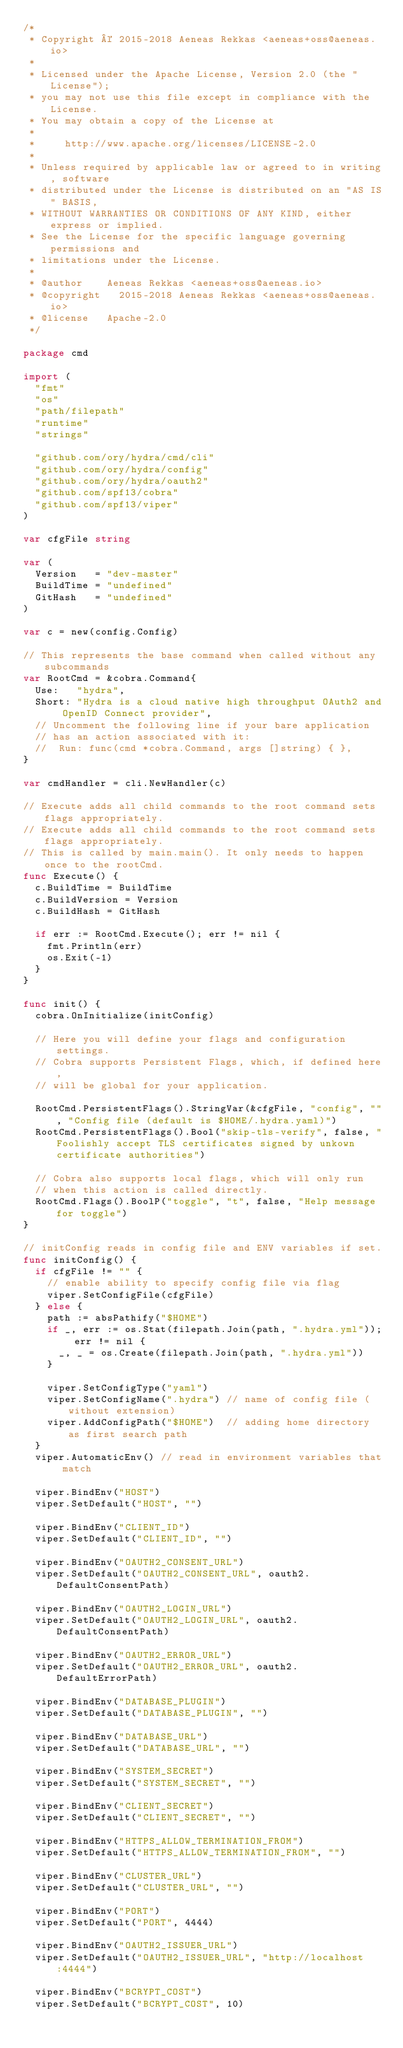<code> <loc_0><loc_0><loc_500><loc_500><_Go_>/*
 * Copyright © 2015-2018 Aeneas Rekkas <aeneas+oss@aeneas.io>
 *
 * Licensed under the Apache License, Version 2.0 (the "License");
 * you may not use this file except in compliance with the License.
 * You may obtain a copy of the License at
 *
 *     http://www.apache.org/licenses/LICENSE-2.0
 *
 * Unless required by applicable law or agreed to in writing, software
 * distributed under the License is distributed on an "AS IS" BASIS,
 * WITHOUT WARRANTIES OR CONDITIONS OF ANY KIND, either express or implied.
 * See the License for the specific language governing permissions and
 * limitations under the License.
 *
 * @author		Aeneas Rekkas <aeneas+oss@aeneas.io>
 * @copyright 	2015-2018 Aeneas Rekkas <aeneas+oss@aeneas.io>
 * @license 	Apache-2.0
 */

package cmd

import (
	"fmt"
	"os"
	"path/filepath"
	"runtime"
	"strings"

	"github.com/ory/hydra/cmd/cli"
	"github.com/ory/hydra/config"
	"github.com/ory/hydra/oauth2"
	"github.com/spf13/cobra"
	"github.com/spf13/viper"
)

var cfgFile string

var (
	Version   = "dev-master"
	BuildTime = "undefined"
	GitHash   = "undefined"
)

var c = new(config.Config)

// This represents the base command when called without any subcommands
var RootCmd = &cobra.Command{
	Use:   "hydra",
	Short: "Hydra is a cloud native high throughput OAuth2 and OpenID Connect provider",
	// Uncomment the following line if your bare application
	// has an action associated with it:
	//	Run: func(cmd *cobra.Command, args []string) { },
}

var cmdHandler = cli.NewHandler(c)

// Execute adds all child commands to the root command sets flags appropriately.
// Execute adds all child commands to the root command sets flags appropriately.
// This is called by main.main(). It only needs to happen once to the rootCmd.
func Execute() {
	c.BuildTime = BuildTime
	c.BuildVersion = Version
	c.BuildHash = GitHash

	if err := RootCmd.Execute(); err != nil {
		fmt.Println(err)
		os.Exit(-1)
	}
}

func init() {
	cobra.OnInitialize(initConfig)

	// Here you will define your flags and configuration settings.
	// Cobra supports Persistent Flags, which, if defined here,
	// will be global for your application.

	RootCmd.PersistentFlags().StringVar(&cfgFile, "config", "", "Config file (default is $HOME/.hydra.yaml)")
	RootCmd.PersistentFlags().Bool("skip-tls-verify", false, "Foolishly accept TLS certificates signed by unkown certificate authorities")

	// Cobra also supports local flags, which will only run
	// when this action is called directly.
	RootCmd.Flags().BoolP("toggle", "t", false, "Help message for toggle")
}

// initConfig reads in config file and ENV variables if set.
func initConfig() {
	if cfgFile != "" {
		// enable ability to specify config file via flag
		viper.SetConfigFile(cfgFile)
	} else {
		path := absPathify("$HOME")
		if _, err := os.Stat(filepath.Join(path, ".hydra.yml")); err != nil {
			_, _ = os.Create(filepath.Join(path, ".hydra.yml"))
		}

		viper.SetConfigType("yaml")
		viper.SetConfigName(".hydra") // name of config file (without extension)
		viper.AddConfigPath("$HOME")  // adding home directory as first search path
	}
	viper.AutomaticEnv() // read in environment variables that match

	viper.BindEnv("HOST")
	viper.SetDefault("HOST", "")

	viper.BindEnv("CLIENT_ID")
	viper.SetDefault("CLIENT_ID", "")

	viper.BindEnv("OAUTH2_CONSENT_URL")
	viper.SetDefault("OAUTH2_CONSENT_URL", oauth2.DefaultConsentPath)

	viper.BindEnv("OAUTH2_LOGIN_URL")
	viper.SetDefault("OAUTH2_LOGIN_URL", oauth2.DefaultConsentPath)

	viper.BindEnv("OAUTH2_ERROR_URL")
	viper.SetDefault("OAUTH2_ERROR_URL", oauth2.DefaultErrorPath)

	viper.BindEnv("DATABASE_PLUGIN")
	viper.SetDefault("DATABASE_PLUGIN", "")

	viper.BindEnv("DATABASE_URL")
	viper.SetDefault("DATABASE_URL", "")

	viper.BindEnv("SYSTEM_SECRET")
	viper.SetDefault("SYSTEM_SECRET", "")

	viper.BindEnv("CLIENT_SECRET")
	viper.SetDefault("CLIENT_SECRET", "")

	viper.BindEnv("HTTPS_ALLOW_TERMINATION_FROM")
	viper.SetDefault("HTTPS_ALLOW_TERMINATION_FROM", "")

	viper.BindEnv("CLUSTER_URL")
	viper.SetDefault("CLUSTER_URL", "")

	viper.BindEnv("PORT")
	viper.SetDefault("PORT", 4444)

	viper.BindEnv("OAUTH2_ISSUER_URL")
	viper.SetDefault("OAUTH2_ISSUER_URL", "http://localhost:4444")

	viper.BindEnv("BCRYPT_COST")
	viper.SetDefault("BCRYPT_COST", 10)
</code> 